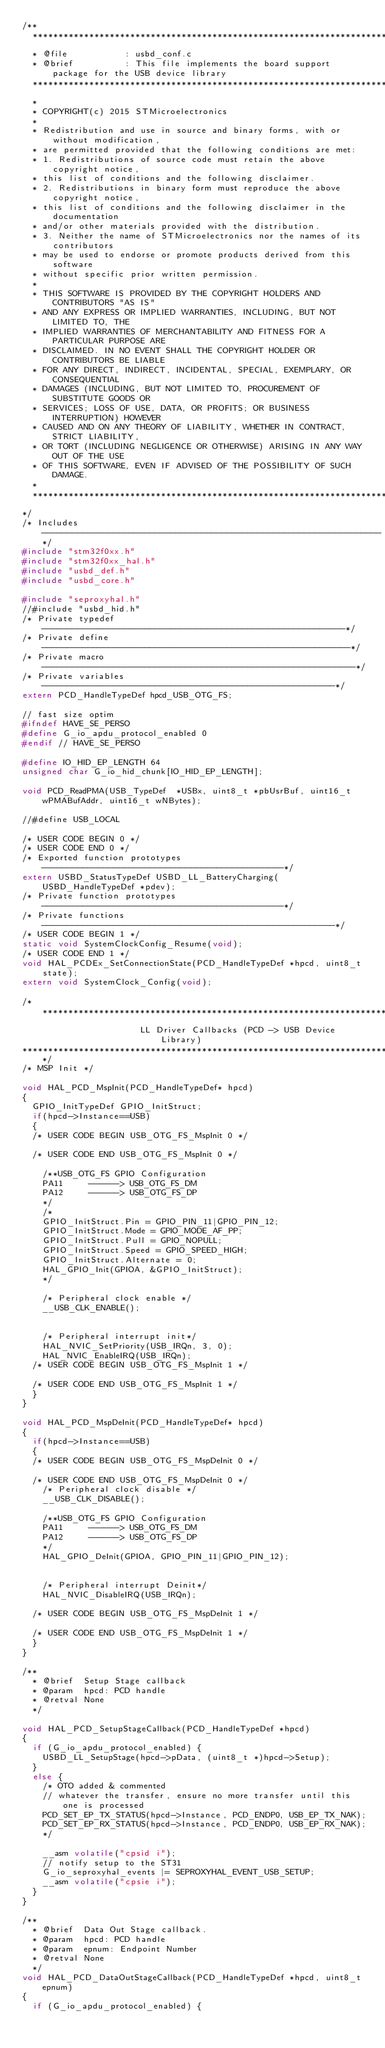Convert code to text. <code><loc_0><loc_0><loc_500><loc_500><_C_>/**
  ******************************************************************************
  * @file           : usbd_conf.c
  * @brief          : This file implements the board support package for the USB device library
  ******************************************************************************
  *
  * COPYRIGHT(c) 2015 STMicroelectronics
  *
  * Redistribution and use in source and binary forms, with or without modification,
  * are permitted provided that the following conditions are met:
  * 1. Redistributions of source code must retain the above copyright notice,
  * this list of conditions and the following disclaimer.
  * 2. Redistributions in binary form must reproduce the above copyright notice,
  * this list of conditions and the following disclaimer in the documentation
  * and/or other materials provided with the distribution.
  * 3. Neither the name of STMicroelectronics nor the names of its contributors
  * may be used to endorse or promote products derived from this software
  * without specific prior written permission.
  *
  * THIS SOFTWARE IS PROVIDED BY THE COPYRIGHT HOLDERS AND CONTRIBUTORS "AS IS"
  * AND ANY EXPRESS OR IMPLIED WARRANTIES, INCLUDING, BUT NOT LIMITED TO, THE
  * IMPLIED WARRANTIES OF MERCHANTABILITY AND FITNESS FOR A PARTICULAR PURPOSE ARE
  * DISCLAIMED. IN NO EVENT SHALL THE COPYRIGHT HOLDER OR CONTRIBUTORS BE LIABLE
  * FOR ANY DIRECT, INDIRECT, INCIDENTAL, SPECIAL, EXEMPLARY, OR CONSEQUENTIAL
  * DAMAGES (INCLUDING, BUT NOT LIMITED TO, PROCUREMENT OF SUBSTITUTE GOODS OR
  * SERVICES; LOSS OF USE, DATA, OR PROFITS; OR BUSINESS INTERRUPTION) HOWEVER
  * CAUSED AND ON ANY THEORY OF LIABILITY, WHETHER IN CONTRACT, STRICT LIABILITY,
  * OR TORT (INCLUDING NEGLIGENCE OR OTHERWISE) ARISING IN ANY WAY OUT OF THE USE
  * OF THIS SOFTWARE, EVEN IF ADVISED OF THE POSSIBILITY OF SUCH DAMAGE.
  *
  ******************************************************************************
*/
/* Includes ------------------------------------------------------------------*/
#include "stm32f0xx.h"
#include "stm32f0xx_hal.h"
#include "usbd_def.h"
#include "usbd_core.h"

#include "seproxyhal.h"
//#include "usbd_hid.h"
/* Private typedef -----------------------------------------------------------*/
/* Private define ------------------------------------------------------------*/
/* Private macro -------------------------------------------------------------*/
/* Private variables ---------------------------------------------------------*/
extern PCD_HandleTypeDef hpcd_USB_OTG_FS;

// fast size optim
#ifndef HAVE_SE_PERSO
#define G_io_apdu_protocol_enabled 0
#endif // HAVE_SE_PERSO

#define IO_HID_EP_LENGTH 64
unsigned char G_io_hid_chunk[IO_HID_EP_LENGTH];

void PCD_ReadPMA(USB_TypeDef  *USBx, uint8_t *pbUsrBuf, uint16_t wPMABufAddr, uint16_t wNBytes);

//#define USB_LOCAL

/* USER CODE BEGIN 0 */
/* USER CODE END 0 */
/* Exported function prototypes -----------------------------------------------*/
extern USBD_StatusTypeDef USBD_LL_BatteryCharging(USBD_HandleTypeDef *pdev);
/* Private function prototypes -----------------------------------------------*/
/* Private functions ---------------------------------------------------------*/
/* USER CODE BEGIN 1 */
static void SystemClockConfig_Resume(void);
/* USER CODE END 1 */
void HAL_PCDEx_SetConnectionState(PCD_HandleTypeDef *hpcd, uint8_t state);
extern void SystemClock_Config(void);

/*******************************************************************************
                       LL Driver Callbacks (PCD -> USB Device Library)
*******************************************************************************/
/* MSP Init */

void HAL_PCD_MspInit(PCD_HandleTypeDef* hpcd)
{
  GPIO_InitTypeDef GPIO_InitStruct;
  if(hpcd->Instance==USB)
  {
  /* USER CODE BEGIN USB_OTG_FS_MspInit 0 */

  /* USER CODE END USB_OTG_FS_MspInit 0 */
  
    /**USB_OTG_FS GPIO Configuration    
    PA11     ------> USB_OTG_FS_DM
    PA12     ------> USB_OTG_FS_DP 
    */
    /*
    GPIO_InitStruct.Pin = GPIO_PIN_11|GPIO_PIN_12;
    GPIO_InitStruct.Mode = GPIO_MODE_AF_PP;
    GPIO_InitStruct.Pull = GPIO_NOPULL;
    GPIO_InitStruct.Speed = GPIO_SPEED_HIGH;
    GPIO_InitStruct.Alternate = 0;
    HAL_GPIO_Init(GPIOA, &GPIO_InitStruct);
    */

    /* Peripheral clock enable */
    __USB_CLK_ENABLE();


    /* Peripheral interrupt init*/
    HAL_NVIC_SetPriority(USB_IRQn, 3, 0);
    HAL_NVIC_EnableIRQ(USB_IRQn);
  /* USER CODE BEGIN USB_OTG_FS_MspInit 1 */

  /* USER CODE END USB_OTG_FS_MspInit 1 */
  }
}

void HAL_PCD_MspDeInit(PCD_HandleTypeDef* hpcd)
{
  if(hpcd->Instance==USB)
  {
  /* USER CODE BEGIN USB_OTG_FS_MspDeInit 0 */

  /* USER CODE END USB_OTG_FS_MspDeInit 0 */
    /* Peripheral clock disable */
    __USB_CLK_DISABLE();
  
    /**USB_OTG_FS GPIO Configuration    
    PA11     ------> USB_OTG_FS_DM
    PA12     ------> USB_OTG_FS_DP 
    */
    HAL_GPIO_DeInit(GPIOA, GPIO_PIN_11|GPIO_PIN_12);


    /* Peripheral interrupt Deinit*/
    HAL_NVIC_DisableIRQ(USB_IRQn);

  /* USER CODE BEGIN USB_OTG_FS_MspDeInit 1 */

  /* USER CODE END USB_OTG_FS_MspDeInit 1 */
  }
}

/**
  * @brief  Setup Stage callback
  * @param  hpcd: PCD handle
  * @retval None
  */

void HAL_PCD_SetupStageCallback(PCD_HandleTypeDef *hpcd)
{
  if (G_io_apdu_protocol_enabled) {
    USBD_LL_SetupStage(hpcd->pData, (uint8_t *)hpcd->Setup);
  }
  else {
    /* OTO added & commented
    // whatever the transfer, ensure no more transfer until this one is processed
    PCD_SET_EP_TX_STATUS(hpcd->Instance, PCD_ENDP0, USB_EP_TX_NAK); 
    PCD_SET_EP_RX_STATUS(hpcd->Instance, PCD_ENDP0, USB_EP_RX_NAK);
    */

    __asm volatile("cpsid i");
    // notify setup to the ST31
    G_io_seproxyhal_events |= SEPROXYHAL_EVENT_USB_SETUP;
    __asm volatile("cpsie i");
  }
}

/**
  * @brief  Data Out Stage callback.
  * @param  hpcd: PCD handle
  * @param  epnum: Endpoint Number
  * @retval None
  */
void HAL_PCD_DataOutStageCallback(PCD_HandleTypeDef *hpcd, uint8_t epnum)
{
  if (G_io_apdu_protocol_enabled) {</code> 